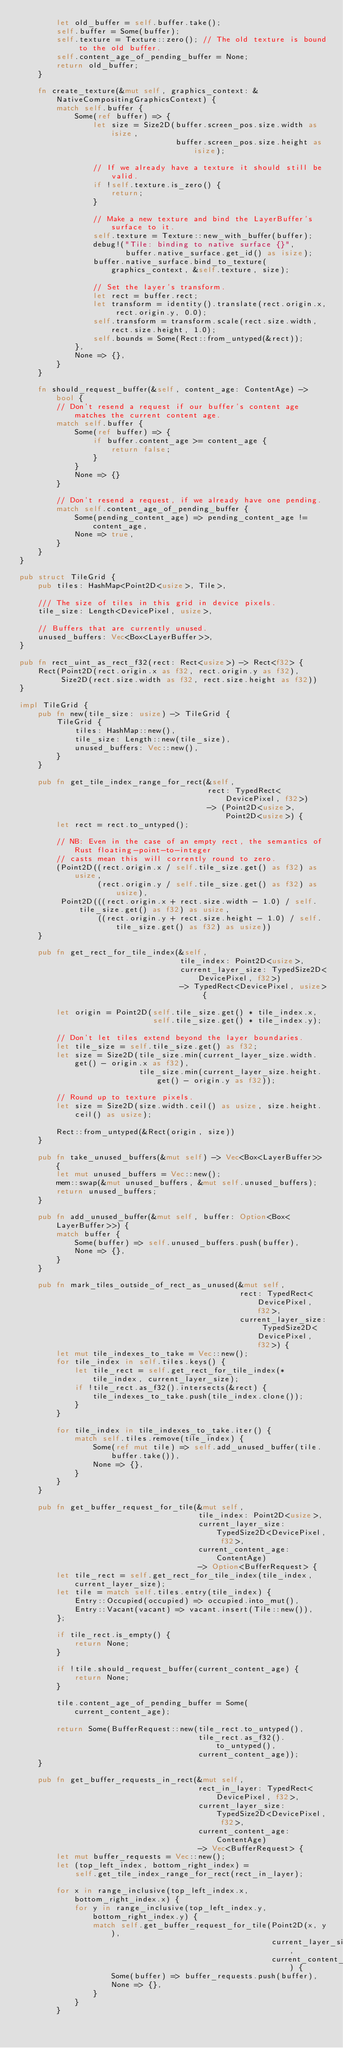<code> <loc_0><loc_0><loc_500><loc_500><_Rust_>        let old_buffer = self.buffer.take();
        self.buffer = Some(buffer);
        self.texture = Texture::zero(); // The old texture is bound to the old buffer.
        self.content_age_of_pending_buffer = None;
        return old_buffer;
    }

    fn create_texture(&mut self, graphics_context: &NativeCompositingGraphicsContext) {
        match self.buffer {
            Some(ref buffer) => {
                let size = Size2D(buffer.screen_pos.size.width as isize,
                                  buffer.screen_pos.size.height as isize);

                // If we already have a texture it should still be valid.
                if !self.texture.is_zero() {
                    return;
                }

                // Make a new texture and bind the LayerBuffer's surface to it.
                self.texture = Texture::new_with_buffer(buffer);
                debug!("Tile: binding to native surface {}",
                       buffer.native_surface.get_id() as isize);
                buffer.native_surface.bind_to_texture(graphics_context, &self.texture, size);

                // Set the layer's transform.
                let rect = buffer.rect;
                let transform = identity().translate(rect.origin.x, rect.origin.y, 0.0);
                self.transform = transform.scale(rect.size.width, rect.size.height, 1.0);
                self.bounds = Some(Rect::from_untyped(&rect));
            },
            None => {},
        }
    }

    fn should_request_buffer(&self, content_age: ContentAge) -> bool {
        // Don't resend a request if our buffer's content age matches the current content age.
        match self.buffer {
            Some(ref buffer) => {
                if buffer.content_age >= content_age {
                    return false;
                }
            }
            None => {}
        }

        // Don't resend a request, if we already have one pending.
        match self.content_age_of_pending_buffer {
            Some(pending_content_age) => pending_content_age != content_age,
            None => true,
        }
    }
}

pub struct TileGrid {
    pub tiles: HashMap<Point2D<usize>, Tile>,

    /// The size of tiles in this grid in device pixels.
    tile_size: Length<DevicePixel, usize>,

    // Buffers that are currently unused.
    unused_buffers: Vec<Box<LayerBuffer>>,
}

pub fn rect_uint_as_rect_f32(rect: Rect<usize>) -> Rect<f32> {
    Rect(Point2D(rect.origin.x as f32, rect.origin.y as f32),
         Size2D(rect.size.width as f32, rect.size.height as f32))
}

impl TileGrid {
    pub fn new(tile_size: usize) -> TileGrid {
        TileGrid {
            tiles: HashMap::new(),
            tile_size: Length::new(tile_size),
            unused_buffers: Vec::new(),
        }
    }

    pub fn get_tile_index_range_for_rect(&self,
                                         rect: TypedRect<DevicePixel, f32>)
                                         -> (Point2D<usize>, Point2D<usize>) {
        let rect = rect.to_untyped();

        // NB: Even in the case of an empty rect, the semantics of Rust floating-point-to-integer
        // casts mean this will corrently round to zero.
        (Point2D((rect.origin.x / self.tile_size.get() as f32) as usize,
                 (rect.origin.y / self.tile_size.get() as f32) as usize),
         Point2D(((rect.origin.x + rect.size.width - 1.0) / self.tile_size.get() as f32) as usize,
                 ((rect.origin.y + rect.size.height - 1.0) / self.tile_size.get() as f32) as usize))
    }

    pub fn get_rect_for_tile_index(&self,
                                   tile_index: Point2D<usize>,
                                   current_layer_size: TypedSize2D<DevicePixel, f32>)
                                   -> TypedRect<DevicePixel, usize> {

        let origin = Point2D(self.tile_size.get() * tile_index.x,
                             self.tile_size.get() * tile_index.y);

        // Don't let tiles extend beyond the layer boundaries.
        let tile_size = self.tile_size.get() as f32;
        let size = Size2D(tile_size.min(current_layer_size.width.get() - origin.x as f32),
                          tile_size.min(current_layer_size.height.get() - origin.y as f32));

        // Round up to texture pixels.
        let size = Size2D(size.width.ceil() as usize, size.height.ceil() as usize);

        Rect::from_untyped(&Rect(origin, size))
    }

    pub fn take_unused_buffers(&mut self) -> Vec<Box<LayerBuffer>> {
        let mut unused_buffers = Vec::new();
        mem::swap(&mut unused_buffers, &mut self.unused_buffers);
        return unused_buffers;
    }

    pub fn add_unused_buffer(&mut self, buffer: Option<Box<LayerBuffer>>) {
        match buffer {
            Some(buffer) => self.unused_buffers.push(buffer),
            None => {},
        }
    }

    pub fn mark_tiles_outside_of_rect_as_unused(&mut self,
                                                rect: TypedRect<DevicePixel, f32>,
                                                current_layer_size: TypedSize2D<DevicePixel, f32>) {
        let mut tile_indexes_to_take = Vec::new();
        for tile_index in self.tiles.keys() {
            let tile_rect = self.get_rect_for_tile_index(*tile_index, current_layer_size);
            if !tile_rect.as_f32().intersects(&rect) {
                tile_indexes_to_take.push(tile_index.clone());
            }
        }

        for tile_index in tile_indexes_to_take.iter() {
            match self.tiles.remove(tile_index) {
                Some(ref mut tile) => self.add_unused_buffer(tile.buffer.take()),
                None => {},
            }
        }
    }

    pub fn get_buffer_request_for_tile(&mut self,
                                       tile_index: Point2D<usize>,
                                       current_layer_size: TypedSize2D<DevicePixel, f32>,
                                       current_content_age: ContentAge)
                                       -> Option<BufferRequest> {
        let tile_rect = self.get_rect_for_tile_index(tile_index, current_layer_size);
        let tile = match self.tiles.entry(tile_index) {
            Entry::Occupied(occupied) => occupied.into_mut(),
            Entry::Vacant(vacant) => vacant.insert(Tile::new()),
        };

        if tile_rect.is_empty() {
            return None;
        }

        if !tile.should_request_buffer(current_content_age) {
            return None;
        }

        tile.content_age_of_pending_buffer = Some(current_content_age);

        return Some(BufferRequest::new(tile_rect.to_untyped(),
                                       tile_rect.as_f32().to_untyped(),
                                       current_content_age));
    }

    pub fn get_buffer_requests_in_rect(&mut self,
                                       rect_in_layer: TypedRect<DevicePixel, f32>,
                                       current_layer_size: TypedSize2D<DevicePixel, f32>,
                                       current_content_age: ContentAge)
                                       -> Vec<BufferRequest> {
        let mut buffer_requests = Vec::new();
        let (top_left_index, bottom_right_index) =
            self.get_tile_index_range_for_rect(rect_in_layer);

        for x in range_inclusive(top_left_index.x, bottom_right_index.x) {
            for y in range_inclusive(top_left_index.y, bottom_right_index.y) {
                match self.get_buffer_request_for_tile(Point2D(x, y),
                                                       current_layer_size,
                                                       current_content_age) {
                    Some(buffer) => buffer_requests.push(buffer),
                    None => {},
                }
            }
        }
</code> 